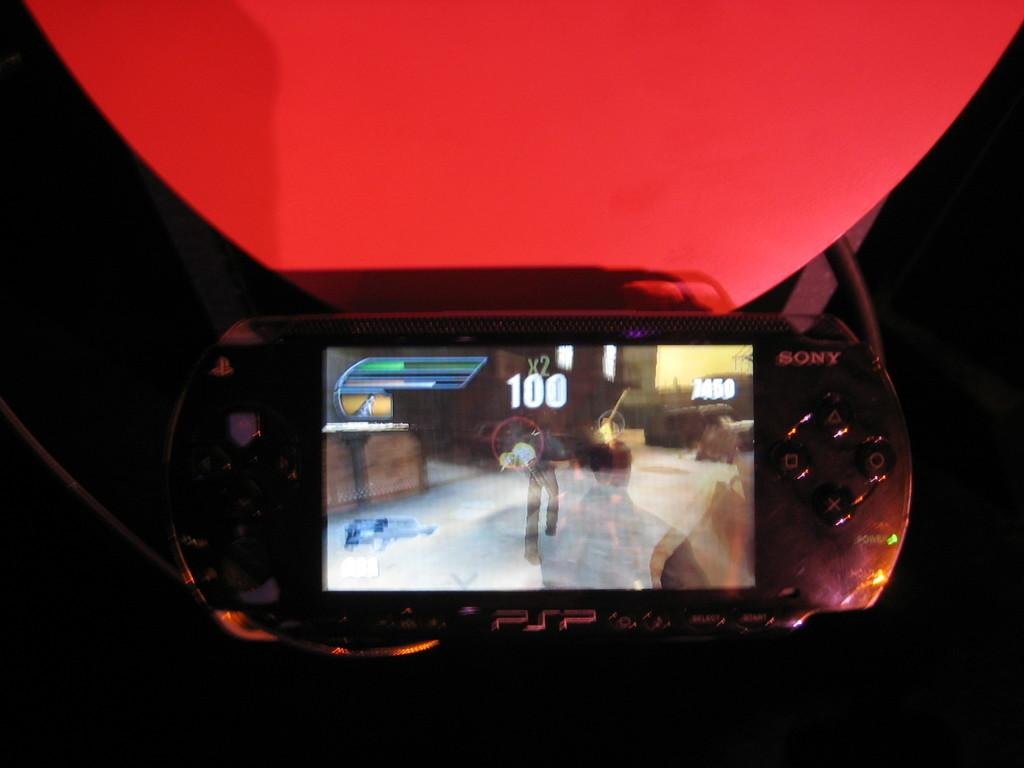What is the main subject of the picture? The main subject of the picture is a video game. What color is the video game? The video game is in black color. Can you describe the background of the image? The background of the image is dark. What type of plantation can be seen in the background of the image? There is no plantation present in the image; the background is dark. How many walls are visible in the image? There are no walls visible in the image; it features a video game and a dark background. 